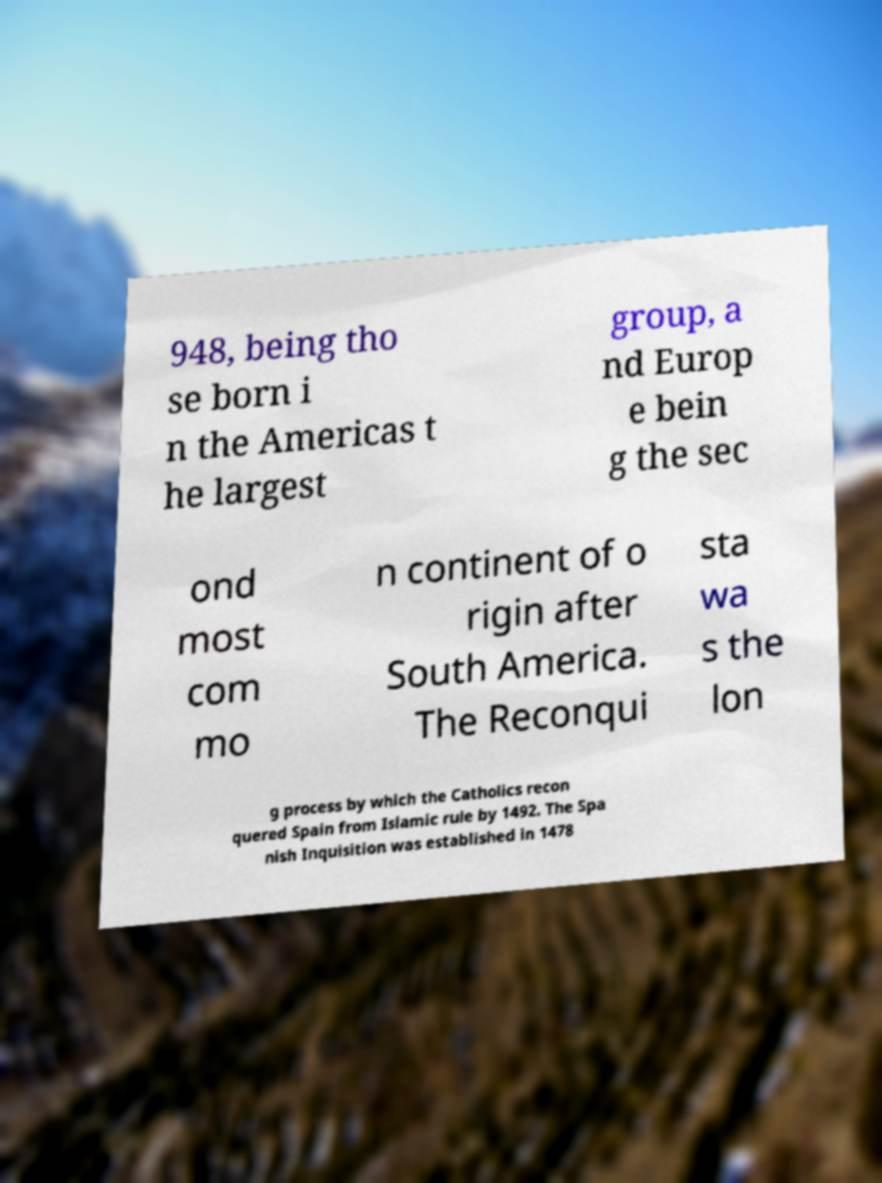I need the written content from this picture converted into text. Can you do that? 948, being tho se born i n the Americas t he largest group, a nd Europ e bein g the sec ond most com mo n continent of o rigin after South America. The Reconqui sta wa s the lon g process by which the Catholics recon quered Spain from Islamic rule by 1492. The Spa nish Inquisition was established in 1478 